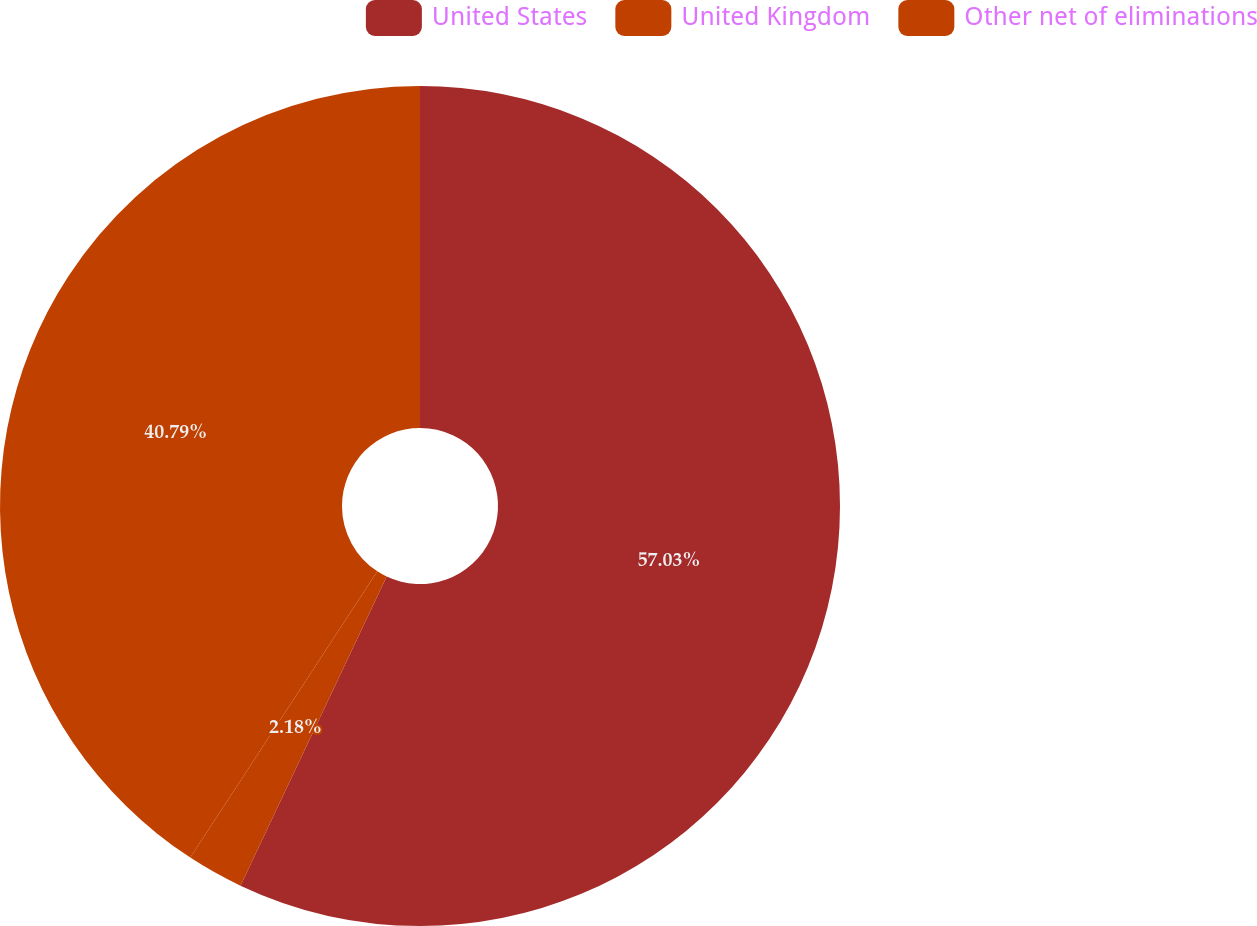Convert chart to OTSL. <chart><loc_0><loc_0><loc_500><loc_500><pie_chart><fcel>United States<fcel>United Kingdom<fcel>Other net of eliminations<nl><fcel>57.03%<fcel>2.18%<fcel>40.79%<nl></chart> 